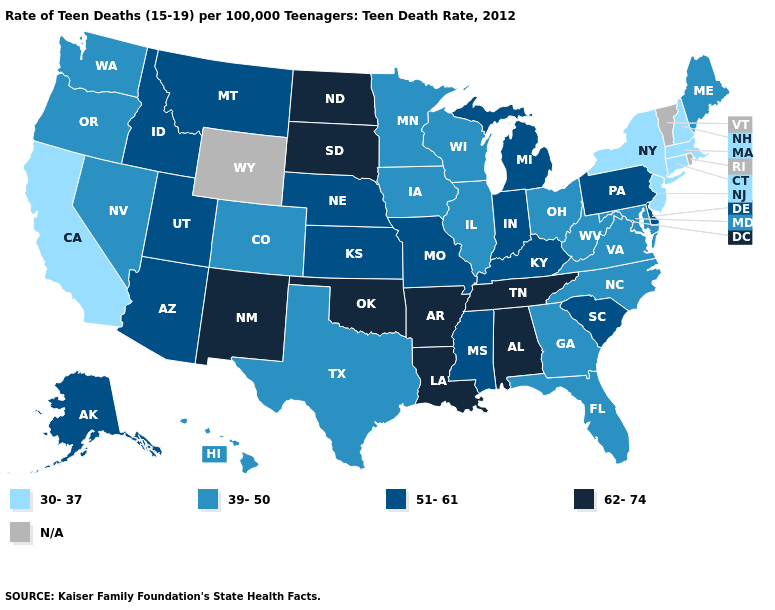What is the lowest value in the USA?
Keep it brief. 30-37. What is the value of New York?
Keep it brief. 30-37. What is the value of Indiana?
Give a very brief answer. 51-61. What is the value of Vermont?
Give a very brief answer. N/A. What is the value of Indiana?
Short answer required. 51-61. Which states have the highest value in the USA?
Short answer required. Alabama, Arkansas, Louisiana, New Mexico, North Dakota, Oklahoma, South Dakota, Tennessee. Name the states that have a value in the range 39-50?
Quick response, please. Colorado, Florida, Georgia, Hawaii, Illinois, Iowa, Maine, Maryland, Minnesota, Nevada, North Carolina, Ohio, Oregon, Texas, Virginia, Washington, West Virginia, Wisconsin. Does North Dakota have the highest value in the USA?
Short answer required. Yes. Among the states that border Arkansas , which have the highest value?
Answer briefly. Louisiana, Oklahoma, Tennessee. Which states have the highest value in the USA?
Answer briefly. Alabama, Arkansas, Louisiana, New Mexico, North Dakota, Oklahoma, South Dakota, Tennessee. What is the lowest value in states that border Michigan?
Keep it brief. 39-50. Which states have the lowest value in the Northeast?
Keep it brief. Connecticut, Massachusetts, New Hampshire, New Jersey, New York. What is the lowest value in states that border Virginia?
Keep it brief. 39-50. 